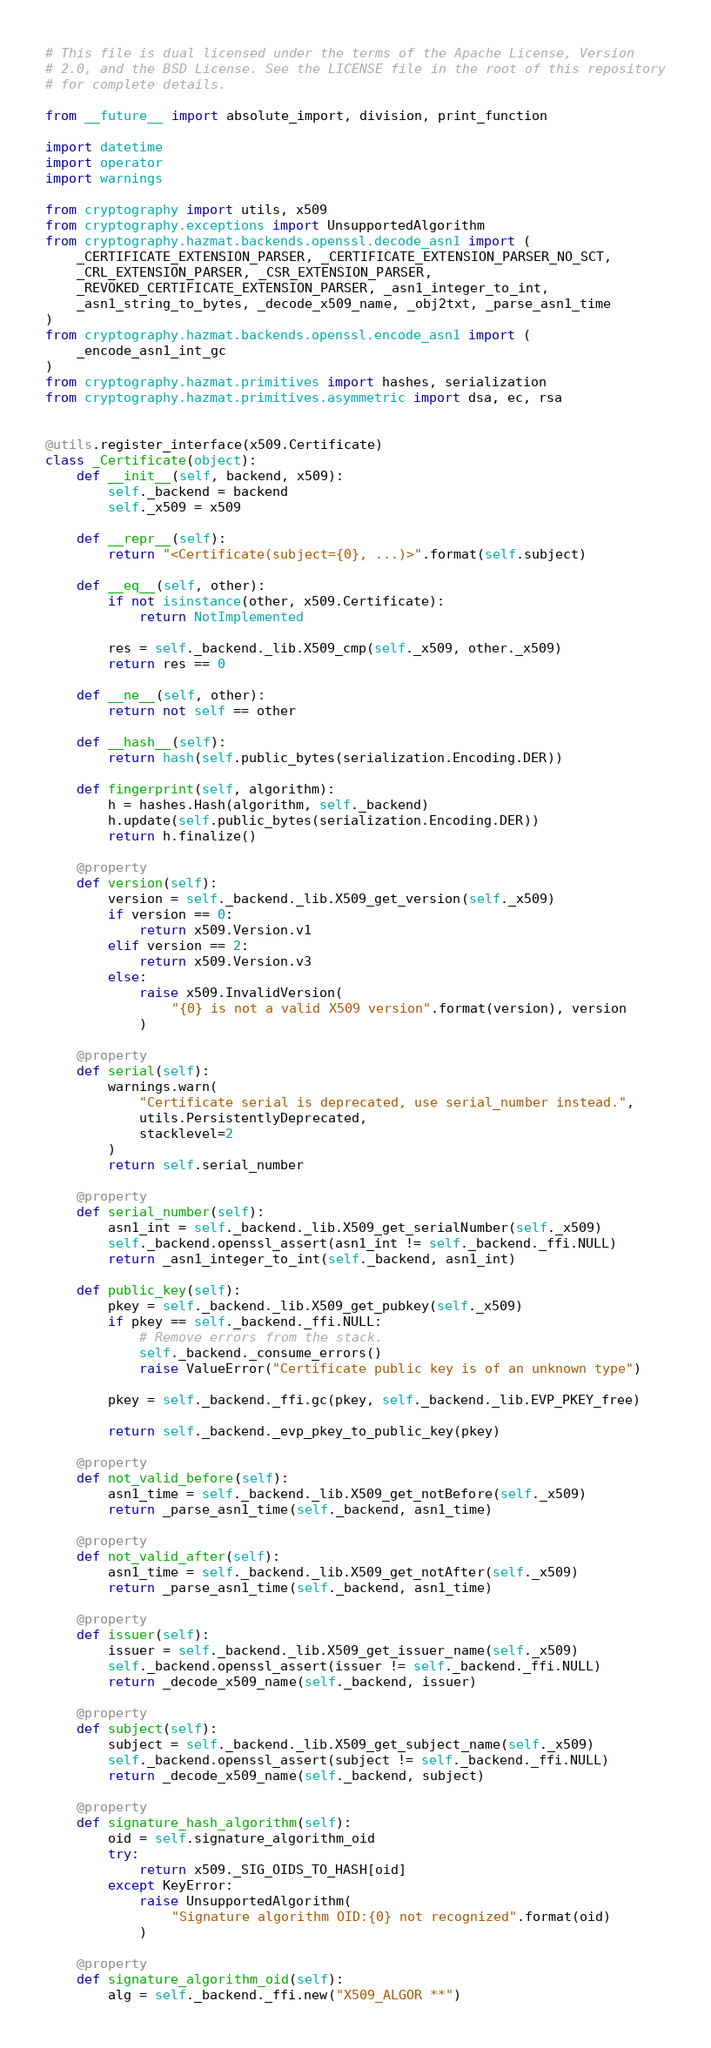<code> <loc_0><loc_0><loc_500><loc_500><_Python_># This file is dual licensed under the terms of the Apache License, Version
# 2.0, and the BSD License. See the LICENSE file in the root of this repository
# for complete details.

from __future__ import absolute_import, division, print_function

import datetime
import operator
import warnings

from cryptography import utils, x509
from cryptography.exceptions import UnsupportedAlgorithm
from cryptography.hazmat.backends.openssl.decode_asn1 import (
    _CERTIFICATE_EXTENSION_PARSER, _CERTIFICATE_EXTENSION_PARSER_NO_SCT,
    _CRL_EXTENSION_PARSER, _CSR_EXTENSION_PARSER,
    _REVOKED_CERTIFICATE_EXTENSION_PARSER, _asn1_integer_to_int,
    _asn1_string_to_bytes, _decode_x509_name, _obj2txt, _parse_asn1_time
)
from cryptography.hazmat.backends.openssl.encode_asn1 import (
    _encode_asn1_int_gc
)
from cryptography.hazmat.primitives import hashes, serialization
from cryptography.hazmat.primitives.asymmetric import dsa, ec, rsa


@utils.register_interface(x509.Certificate)
class _Certificate(object):
    def __init__(self, backend, x509):
        self._backend = backend
        self._x509 = x509

    def __repr__(self):
        return "<Certificate(subject={0}, ...)>".format(self.subject)

    def __eq__(self, other):
        if not isinstance(other, x509.Certificate):
            return NotImplemented

        res = self._backend._lib.X509_cmp(self._x509, other._x509)
        return res == 0

    def __ne__(self, other):
        return not self == other

    def __hash__(self):
        return hash(self.public_bytes(serialization.Encoding.DER))

    def fingerprint(self, algorithm):
        h = hashes.Hash(algorithm, self._backend)
        h.update(self.public_bytes(serialization.Encoding.DER))
        return h.finalize()

    @property
    def version(self):
        version = self._backend._lib.X509_get_version(self._x509)
        if version == 0:
            return x509.Version.v1
        elif version == 2:
            return x509.Version.v3
        else:
            raise x509.InvalidVersion(
                "{0} is not a valid X509 version".format(version), version
            )

    @property
    def serial(self):
        warnings.warn(
            "Certificate serial is deprecated, use serial_number instead.",
            utils.PersistentlyDeprecated,
            stacklevel=2
        )
        return self.serial_number

    @property
    def serial_number(self):
        asn1_int = self._backend._lib.X509_get_serialNumber(self._x509)
        self._backend.openssl_assert(asn1_int != self._backend._ffi.NULL)
        return _asn1_integer_to_int(self._backend, asn1_int)

    def public_key(self):
        pkey = self._backend._lib.X509_get_pubkey(self._x509)
        if pkey == self._backend._ffi.NULL:
            # Remove errors from the stack.
            self._backend._consume_errors()
            raise ValueError("Certificate public key is of an unknown type")

        pkey = self._backend._ffi.gc(pkey, self._backend._lib.EVP_PKEY_free)

        return self._backend._evp_pkey_to_public_key(pkey)

    @property
    def not_valid_before(self):
        asn1_time = self._backend._lib.X509_get_notBefore(self._x509)
        return _parse_asn1_time(self._backend, asn1_time)

    @property
    def not_valid_after(self):
        asn1_time = self._backend._lib.X509_get_notAfter(self._x509)
        return _parse_asn1_time(self._backend, asn1_time)

    @property
    def issuer(self):
        issuer = self._backend._lib.X509_get_issuer_name(self._x509)
        self._backend.openssl_assert(issuer != self._backend._ffi.NULL)
        return _decode_x509_name(self._backend, issuer)

    @property
    def subject(self):
        subject = self._backend._lib.X509_get_subject_name(self._x509)
        self._backend.openssl_assert(subject != self._backend._ffi.NULL)
        return _decode_x509_name(self._backend, subject)

    @property
    def signature_hash_algorithm(self):
        oid = self.signature_algorithm_oid
        try:
            return x509._SIG_OIDS_TO_HASH[oid]
        except KeyError:
            raise UnsupportedAlgorithm(
                "Signature algorithm OID:{0} not recognized".format(oid)
            )

    @property
    def signature_algorithm_oid(self):
        alg = self._backend._ffi.new("X509_ALGOR **")</code> 